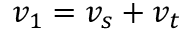Convert formula to latex. <formula><loc_0><loc_0><loc_500><loc_500>v _ { 1 } = v _ { s } + v _ { t }</formula> 